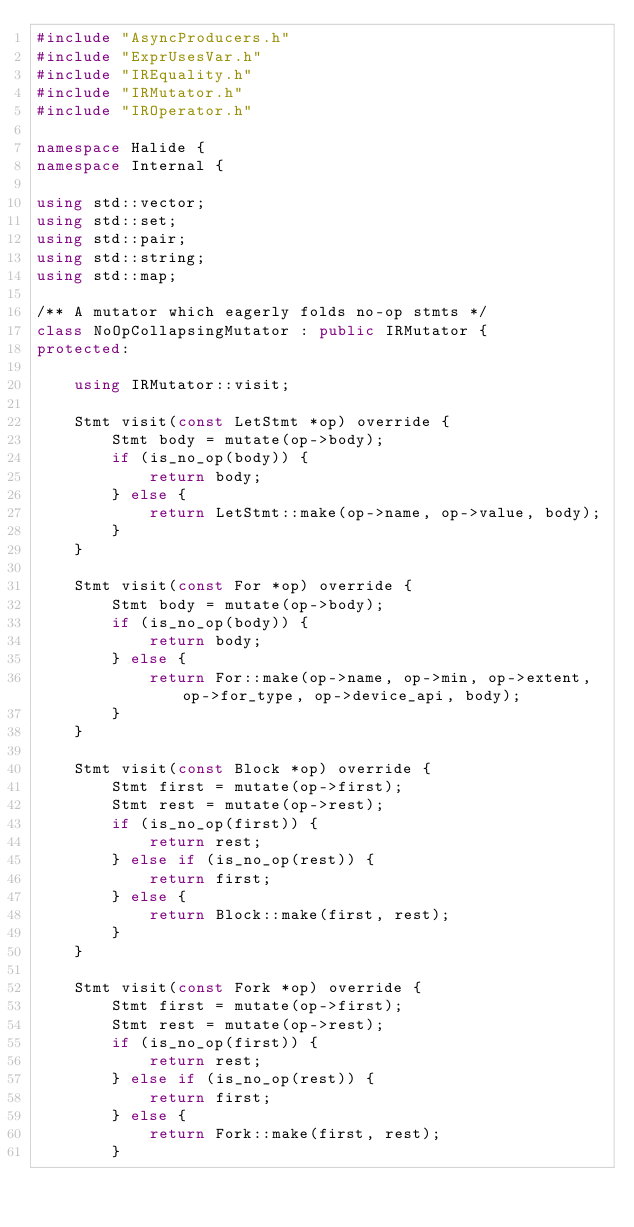<code> <loc_0><loc_0><loc_500><loc_500><_C++_>#include "AsyncProducers.h"
#include "ExprUsesVar.h"
#include "IREquality.h"
#include "IRMutator.h"
#include "IROperator.h"

namespace Halide {
namespace Internal {

using std::vector;
using std::set;
using std::pair;
using std::string;
using std::map;

/** A mutator which eagerly folds no-op stmts */
class NoOpCollapsingMutator : public IRMutator {
protected:

    using IRMutator::visit;

    Stmt visit(const LetStmt *op) override {
        Stmt body = mutate(op->body);
        if (is_no_op(body)) {
            return body;
        } else {
            return LetStmt::make(op->name, op->value, body);
        }
    }

    Stmt visit(const For *op) override {
        Stmt body = mutate(op->body);
        if (is_no_op(body)) {
            return body;
        } else {
            return For::make(op->name, op->min, op->extent, op->for_type, op->device_api, body);
        }
    }

    Stmt visit(const Block *op) override {
        Stmt first = mutate(op->first);
        Stmt rest = mutate(op->rest);
        if (is_no_op(first)) {
            return rest;
        } else if (is_no_op(rest)) {
            return first;
        } else {
            return Block::make(first, rest);
        }
    }

    Stmt visit(const Fork *op) override {
        Stmt first = mutate(op->first);
        Stmt rest = mutate(op->rest);
        if (is_no_op(first)) {
            return rest;
        } else if (is_no_op(rest)) {
            return first;
        } else {
            return Fork::make(first, rest);
        }</code> 